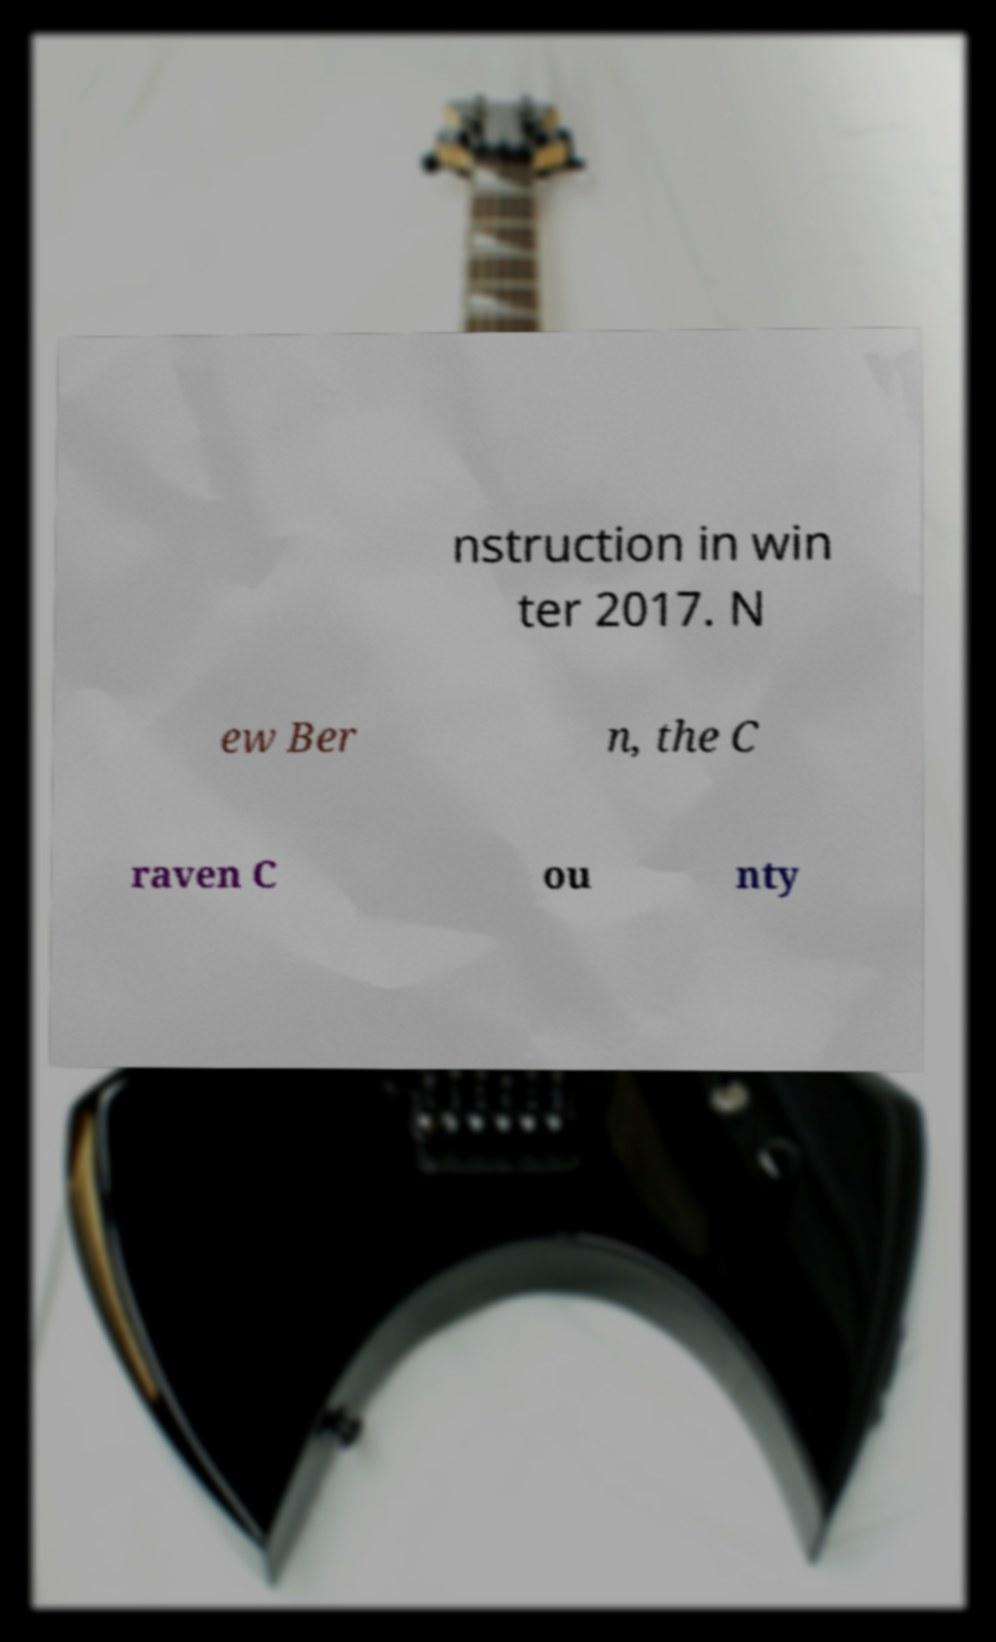What messages or text are displayed in this image? I need them in a readable, typed format. nstruction in win ter 2017. N ew Ber n, the C raven C ou nty 